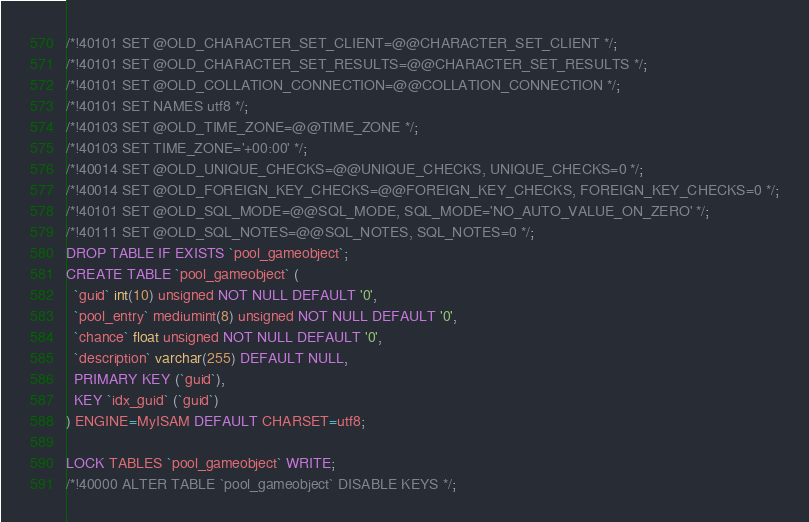Convert code to text. <code><loc_0><loc_0><loc_500><loc_500><_SQL_>
/*!40101 SET @OLD_CHARACTER_SET_CLIENT=@@CHARACTER_SET_CLIENT */;
/*!40101 SET @OLD_CHARACTER_SET_RESULTS=@@CHARACTER_SET_RESULTS */;
/*!40101 SET @OLD_COLLATION_CONNECTION=@@COLLATION_CONNECTION */;
/*!40101 SET NAMES utf8 */;
/*!40103 SET @OLD_TIME_ZONE=@@TIME_ZONE */;
/*!40103 SET TIME_ZONE='+00:00' */;
/*!40014 SET @OLD_UNIQUE_CHECKS=@@UNIQUE_CHECKS, UNIQUE_CHECKS=0 */;
/*!40014 SET @OLD_FOREIGN_KEY_CHECKS=@@FOREIGN_KEY_CHECKS, FOREIGN_KEY_CHECKS=0 */;
/*!40101 SET @OLD_SQL_MODE=@@SQL_MODE, SQL_MODE='NO_AUTO_VALUE_ON_ZERO' */;
/*!40111 SET @OLD_SQL_NOTES=@@SQL_NOTES, SQL_NOTES=0 */;
DROP TABLE IF EXISTS `pool_gameobject`;
CREATE TABLE `pool_gameobject` (
  `guid` int(10) unsigned NOT NULL DEFAULT '0',
  `pool_entry` mediumint(8) unsigned NOT NULL DEFAULT '0',
  `chance` float unsigned NOT NULL DEFAULT '0',
  `description` varchar(255) DEFAULT NULL,
  PRIMARY KEY (`guid`),
  KEY `idx_guid` (`guid`)
) ENGINE=MyISAM DEFAULT CHARSET=utf8;

LOCK TABLES `pool_gameobject` WRITE;
/*!40000 ALTER TABLE `pool_gameobject` DISABLE KEYS */;</code> 